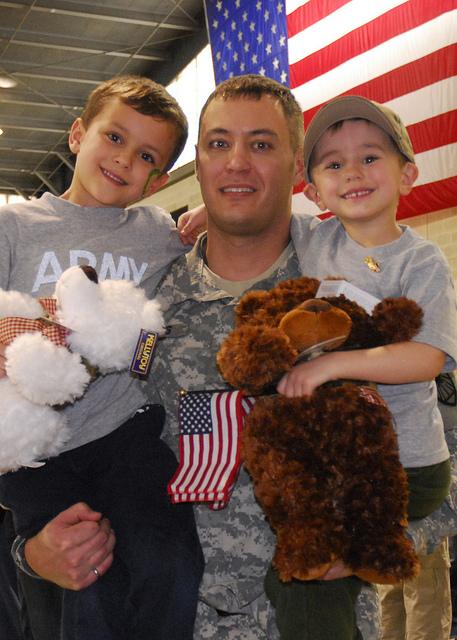What branch of the military is this man in?
Short answer required. Army. What is the adult's profession?
Quick response, please. Military. What do the boys have in their arms?
Give a very brief answer. Teddy bears. 